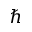<formula> <loc_0><loc_0><loc_500><loc_500>\hbar</formula> 